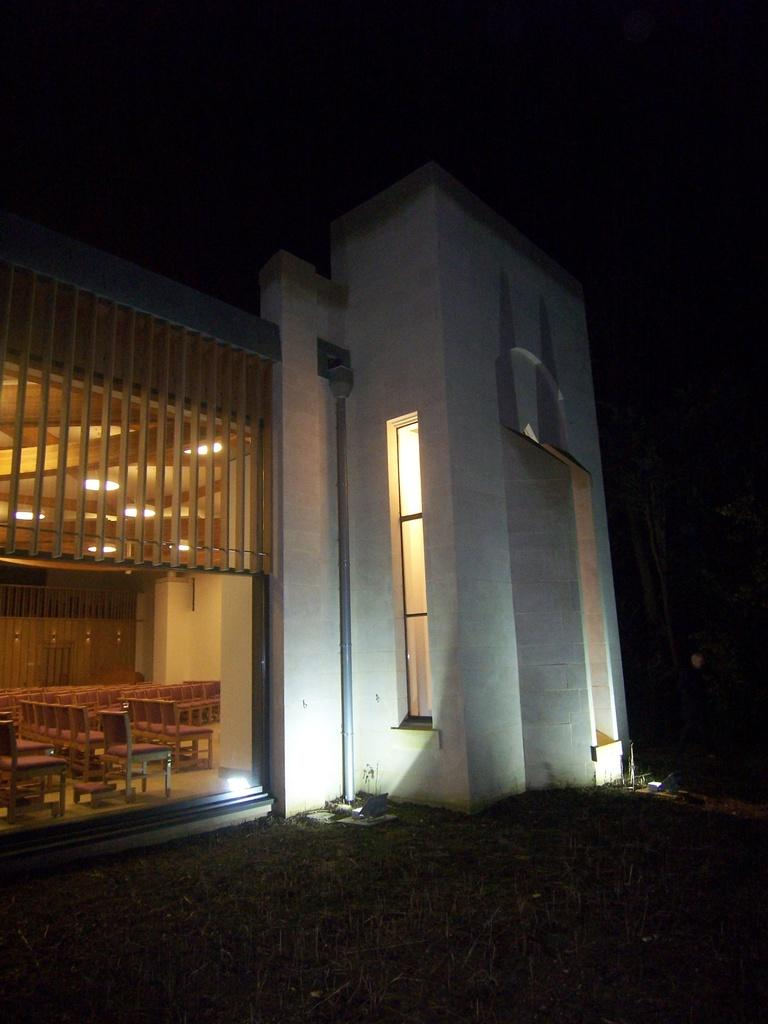What is the main structure in the picture? There is a building in the picture. Where are the chairs located in relation to the building? The chairs are in the left corner of the building. What is above the chairs? There are lights above the chairs. What type of stew is being served in the picture? There is no stew present in the picture; it features a building with chairs and lights. 